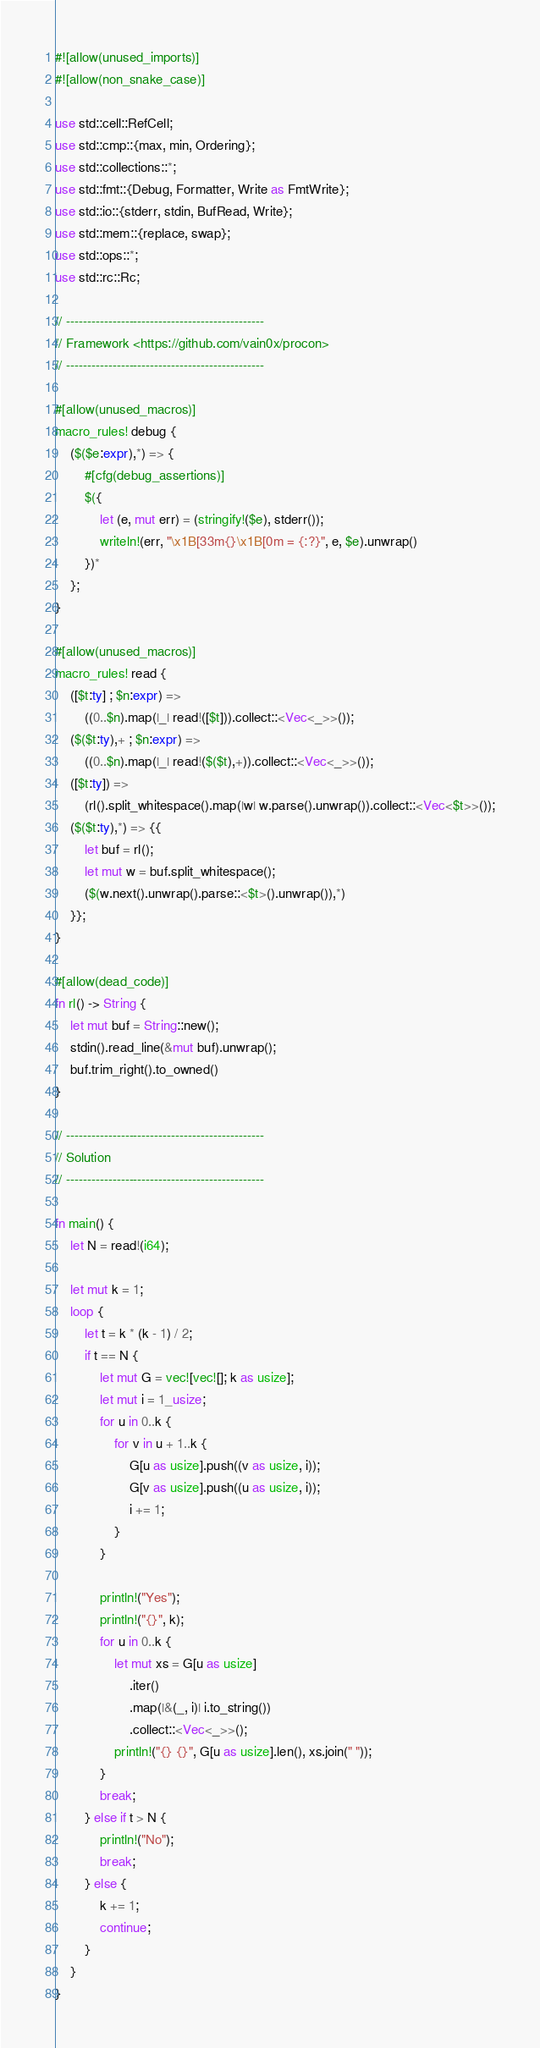Convert code to text. <code><loc_0><loc_0><loc_500><loc_500><_Rust_>#![allow(unused_imports)]
#![allow(non_snake_case)]

use std::cell::RefCell;
use std::cmp::{max, min, Ordering};
use std::collections::*;
use std::fmt::{Debug, Formatter, Write as FmtWrite};
use std::io::{stderr, stdin, BufRead, Write};
use std::mem::{replace, swap};
use std::ops::*;
use std::rc::Rc;

// -----------------------------------------------
// Framework <https://github.com/vain0x/procon>
// -----------------------------------------------

#[allow(unused_macros)]
macro_rules! debug {
    ($($e:expr),*) => {
        #[cfg(debug_assertions)]
        $({
            let (e, mut err) = (stringify!($e), stderr());
            writeln!(err, "\x1B[33m{}\x1B[0m = {:?}", e, $e).unwrap()
        })*
    };
}

#[allow(unused_macros)]
macro_rules! read {
    ([$t:ty] ; $n:expr) =>
        ((0..$n).map(|_| read!([$t])).collect::<Vec<_>>());
    ($($t:ty),+ ; $n:expr) =>
        ((0..$n).map(|_| read!($($t),+)).collect::<Vec<_>>());
    ([$t:ty]) =>
        (rl().split_whitespace().map(|w| w.parse().unwrap()).collect::<Vec<$t>>());
    ($($t:ty),*) => {{
        let buf = rl();
        let mut w = buf.split_whitespace();
        ($(w.next().unwrap().parse::<$t>().unwrap()),*)
    }};
}

#[allow(dead_code)]
fn rl() -> String {
    let mut buf = String::new();
    stdin().read_line(&mut buf).unwrap();
    buf.trim_right().to_owned()
}

// -----------------------------------------------
// Solution
// -----------------------------------------------

fn main() {
    let N = read!(i64);

    let mut k = 1;
    loop {
        let t = k * (k - 1) / 2;
        if t == N {
            let mut G = vec![vec![]; k as usize];
            let mut i = 1_usize;
            for u in 0..k {
                for v in u + 1..k {
                    G[u as usize].push((v as usize, i));
                    G[v as usize].push((u as usize, i));
                    i += 1;
                }
            }

            println!("Yes");
            println!("{}", k);
            for u in 0..k {
                let mut xs = G[u as usize]
                    .iter()
                    .map(|&(_, i)| i.to_string())
                    .collect::<Vec<_>>();
                println!("{} {}", G[u as usize].len(), xs.join(" "));
            }
            break;
        } else if t > N {
            println!("No");
            break;
        } else {
            k += 1;
            continue;
        }
    }
}
</code> 